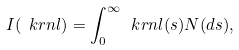Convert formula to latex. <formula><loc_0><loc_0><loc_500><loc_500>I ( \ k r n l ) = \int _ { 0 } ^ { \infty } \ k r n l ( s ) N ( d s ) ,</formula> 